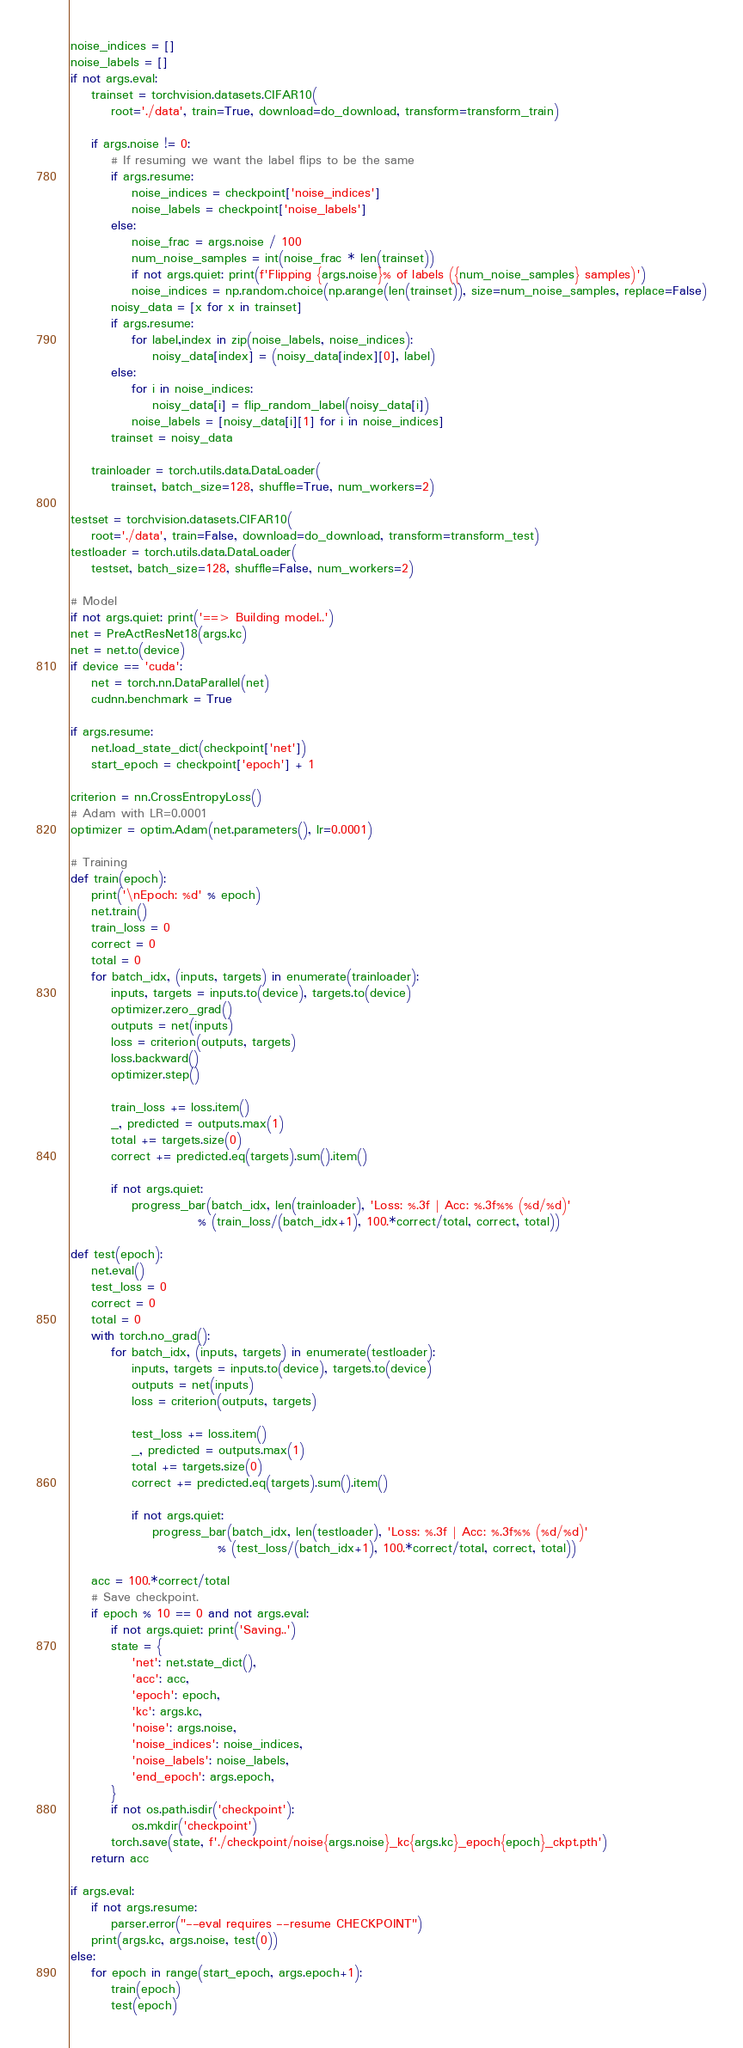<code> <loc_0><loc_0><loc_500><loc_500><_Python_>noise_indices = []
noise_labels = []
if not args.eval:
    trainset = torchvision.datasets.CIFAR10(
        root='./data', train=True, download=do_download, transform=transform_train)

    if args.noise != 0:
        # If resuming we want the label flips to be the same
        if args.resume:
            noise_indices = checkpoint['noise_indices']
            noise_labels = checkpoint['noise_labels']
        else:
            noise_frac = args.noise / 100
            num_noise_samples = int(noise_frac * len(trainset))
            if not args.quiet: print(f'Flipping {args.noise}% of labels ({num_noise_samples} samples)')
            noise_indices = np.random.choice(np.arange(len(trainset)), size=num_noise_samples, replace=False)
        noisy_data = [x for x in trainset]
        if args.resume:
            for label,index in zip(noise_labels, noise_indices):
                noisy_data[index] = (noisy_data[index][0], label)
        else:
            for i in noise_indices:
                noisy_data[i] = flip_random_label(noisy_data[i])
            noise_labels = [noisy_data[i][1] for i in noise_indices]
        trainset = noisy_data

    trainloader = torch.utils.data.DataLoader(
        trainset, batch_size=128, shuffle=True, num_workers=2)

testset = torchvision.datasets.CIFAR10(
    root='./data', train=False, download=do_download, transform=transform_test)
testloader = torch.utils.data.DataLoader(
    testset, batch_size=128, shuffle=False, num_workers=2)

# Model
if not args.quiet: print('==> Building model..')
net = PreActResNet18(args.kc)
net = net.to(device)
if device == 'cuda':
    net = torch.nn.DataParallel(net)
    cudnn.benchmark = True

if args.resume:
    net.load_state_dict(checkpoint['net'])
    start_epoch = checkpoint['epoch'] + 1

criterion = nn.CrossEntropyLoss()
# Adam with LR=0.0001
optimizer = optim.Adam(net.parameters(), lr=0.0001)

# Training
def train(epoch):
    print('\nEpoch: %d' % epoch)
    net.train()
    train_loss = 0
    correct = 0
    total = 0
    for batch_idx, (inputs, targets) in enumerate(trainloader):
        inputs, targets = inputs.to(device), targets.to(device)
        optimizer.zero_grad()
        outputs = net(inputs)
        loss = criterion(outputs, targets)
        loss.backward()
        optimizer.step()

        train_loss += loss.item()
        _, predicted = outputs.max(1)
        total += targets.size(0)
        correct += predicted.eq(targets).sum().item()

        if not args.quiet:
            progress_bar(batch_idx, len(trainloader), 'Loss: %.3f | Acc: %.3f%% (%d/%d)'
                         % (train_loss/(batch_idx+1), 100.*correct/total, correct, total))

def test(epoch):
    net.eval()
    test_loss = 0
    correct = 0
    total = 0
    with torch.no_grad():
        for batch_idx, (inputs, targets) in enumerate(testloader):
            inputs, targets = inputs.to(device), targets.to(device)
            outputs = net(inputs)
            loss = criterion(outputs, targets)

            test_loss += loss.item()
            _, predicted = outputs.max(1)
            total += targets.size(0)
            correct += predicted.eq(targets).sum().item()

            if not args.quiet:
                progress_bar(batch_idx, len(testloader), 'Loss: %.3f | Acc: %.3f%% (%d/%d)'
                             % (test_loss/(batch_idx+1), 100.*correct/total, correct, total))

    acc = 100.*correct/total
    # Save checkpoint.
    if epoch % 10 == 0 and not args.eval:
        if not args.quiet: print('Saving..')
        state = {
            'net': net.state_dict(),
            'acc': acc,
            'epoch': epoch,
            'kc': args.kc,
            'noise': args.noise,
            'noise_indices': noise_indices,
            'noise_labels': noise_labels,
            'end_epoch': args.epoch,
        }
        if not os.path.isdir('checkpoint'):
            os.mkdir('checkpoint')
        torch.save(state, f'./checkpoint/noise{args.noise}_kc{args.kc}_epoch{epoch}_ckpt.pth')
    return acc

if args.eval:
    if not args.resume:
        parser.error("--eval requires --resume CHECKPOINT")
    print(args.kc, args.noise, test(0))
else:
    for epoch in range(start_epoch, args.epoch+1):
        train(epoch)
        test(epoch)
</code> 